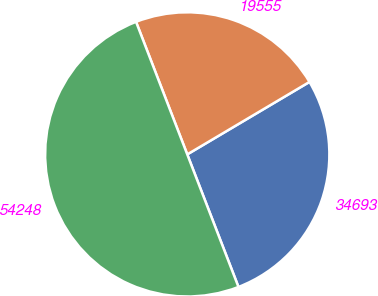Convert chart. <chart><loc_0><loc_0><loc_500><loc_500><pie_chart><fcel>34693<fcel>19555<fcel>54248<nl><fcel>27.65%<fcel>22.35%<fcel>50.0%<nl></chart> 